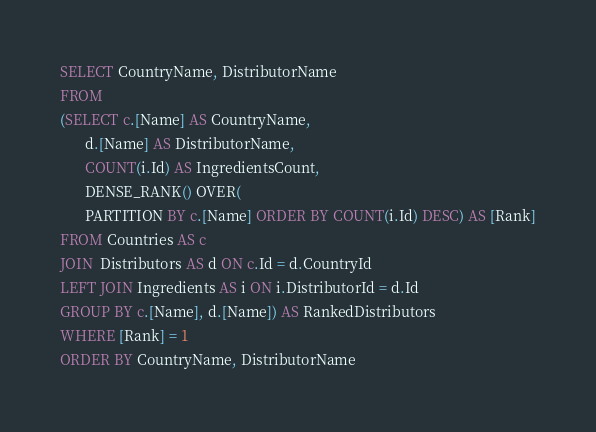<code> <loc_0><loc_0><loc_500><loc_500><_SQL_>SELECT CountryName, DistributorName
FROM
(SELECT c.[Name] AS CountryName, 
	   d.[Name] AS DistributorName,  
	   COUNT(i.Id) AS IngredientsCount,
       DENSE_RANK() OVER(
	   PARTITION BY c.[Name] ORDER BY COUNT(i.Id) DESC) AS [Rank]
FROM Countries AS c 
JOIN  Distributors AS d ON c.Id = d.CountryId
LEFT JOIN Ingredients AS i ON i.DistributorId = d.Id
GROUP BY c.[Name], d.[Name]) AS RankedDistributors
WHERE [Rank] = 1
ORDER BY CountryName, DistributorName
</code> 